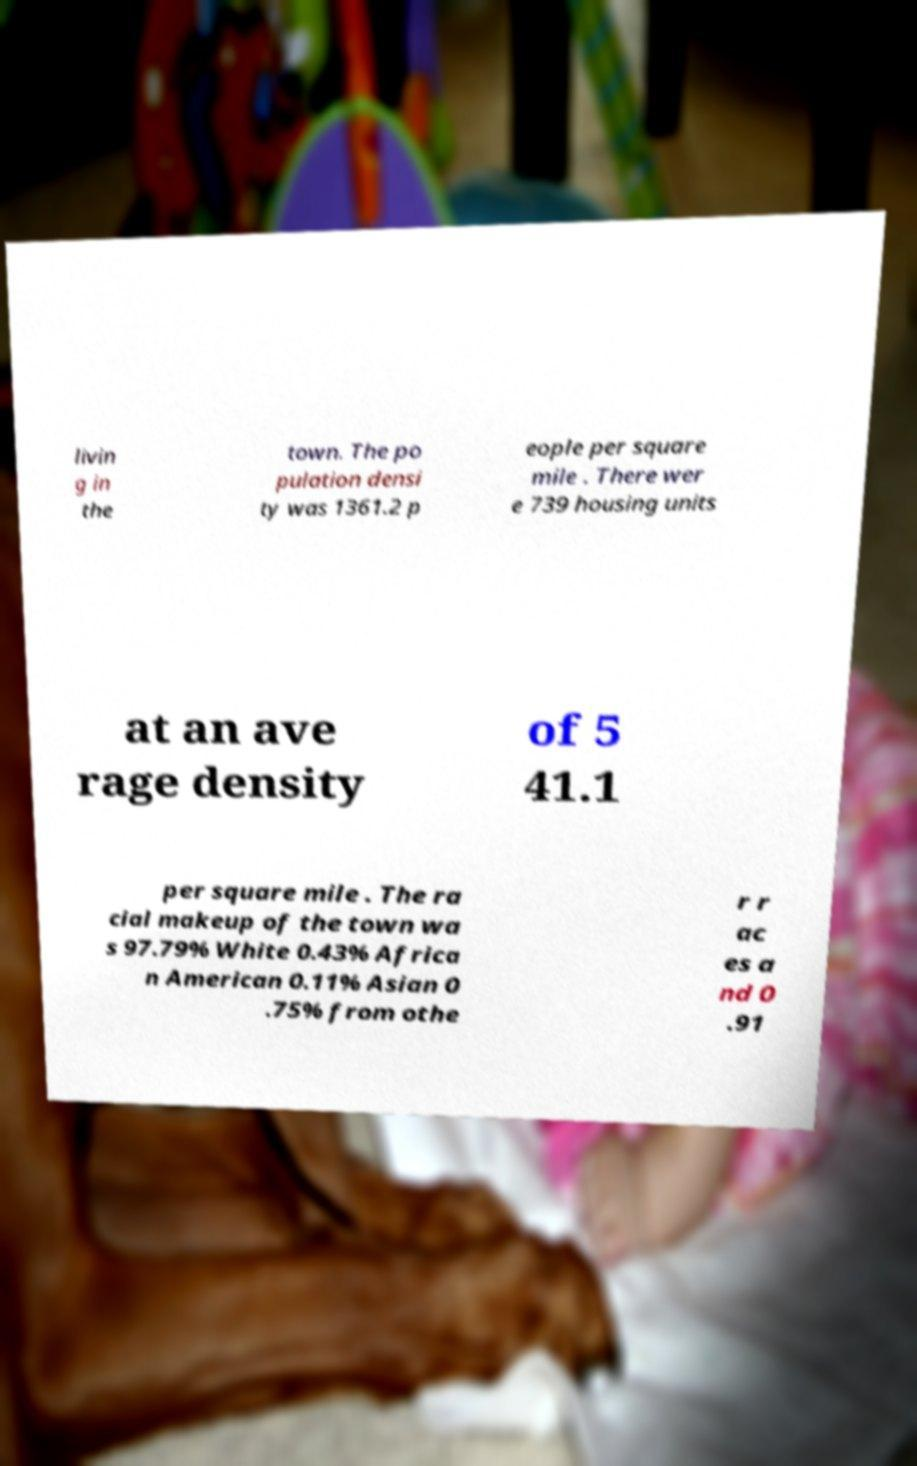Could you extract and type out the text from this image? livin g in the town. The po pulation densi ty was 1361.2 p eople per square mile . There wer e 739 housing units at an ave rage density of 5 41.1 per square mile . The ra cial makeup of the town wa s 97.79% White 0.43% Africa n American 0.11% Asian 0 .75% from othe r r ac es a nd 0 .91 